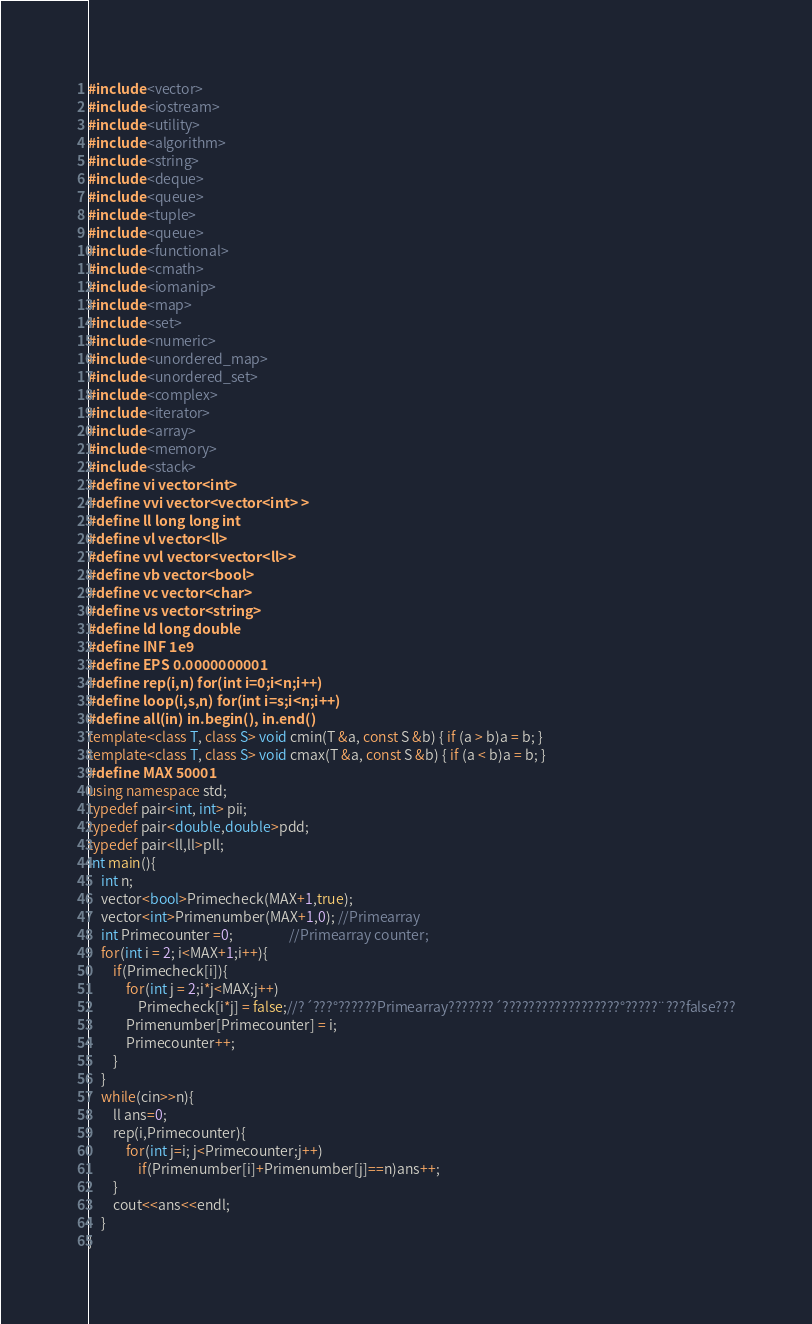<code> <loc_0><loc_0><loc_500><loc_500><_C++_>#include <vector>
#include <iostream>
#include <utility>
#include <algorithm>
#include <string>
#include <deque>
#include <queue>
#include <tuple>
#include <queue>
#include <functional>
#include <cmath>
#include <iomanip>
#include <map>
#include <set>
#include <numeric>
#include <unordered_map>
#include <unordered_set>
#include <complex>
#include <iterator>
#include <array>
#include <memory>
#include <stack>
#define vi vector<int>
#define vvi vector<vector<int> >
#define ll long long int
#define vl vector<ll>
#define vvl vector<vector<ll>>
#define vb vector<bool>
#define vc vector<char>
#define vs vector<string>
#define ld long double
#define INF 1e9
#define EPS 0.0000000001
#define rep(i,n) for(int i=0;i<n;i++)
#define loop(i,s,n) for(int i=s;i<n;i++)
#define all(in) in.begin(), in.end()
template<class T, class S> void cmin(T &a, const S &b) { if (a > b)a = b; }
template<class T, class S> void cmax(T &a, const S &b) { if (a < b)a = b; }
#define MAX 50001
using namespace std;
typedef pair<int, int> pii;
typedef pair<double,double>pdd;
typedef pair<ll,ll>pll;
int main(){
    int n;
    vector<bool>Primecheck(MAX+1,true);
    vector<int>Primenumber(MAX+1,0); //Primearray
    int Primecounter =0;                  //Primearray counter;
    for(int i = 2; i<MAX+1;i++){
        if(Primecheck[i]){
            for(int j = 2;i*j<MAX;j++)
                Primecheck[i*j] = false;//?´???°??????Primearray???????´??????????????????°?????¨???false???
            Primenumber[Primecounter] = i;
            Primecounter++;
        }
    }
    while(cin>>n){
        ll ans=0;
        rep(i,Primecounter){
            for(int j=i; j<Primecounter;j++)
                if(Primenumber[i]+Primenumber[j]==n)ans++;
        }
        cout<<ans<<endl;
    }
}</code> 